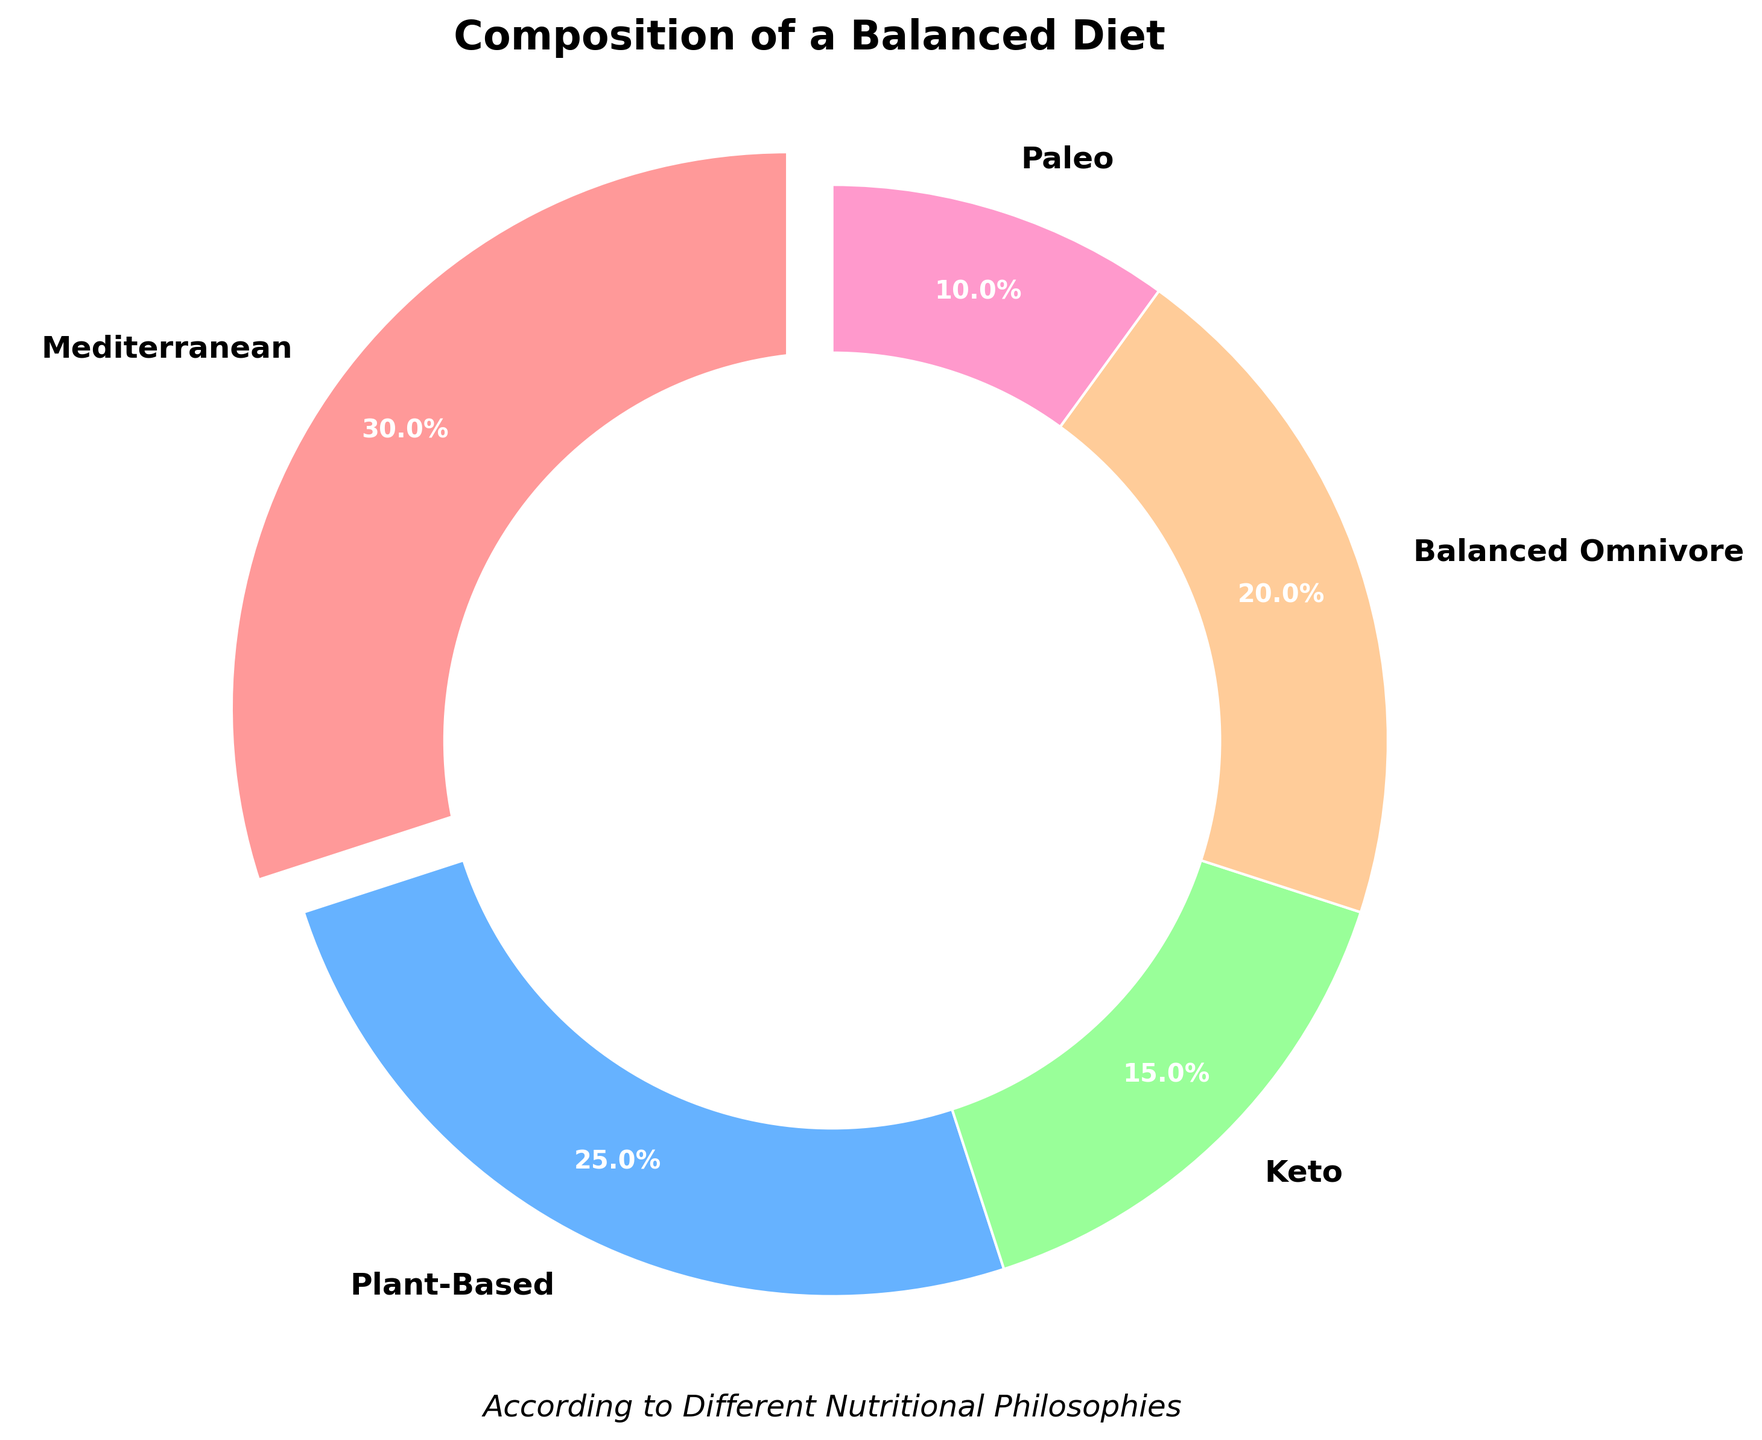What is the total percentage of the Mediterranean and Plant-Based diets? Add up the percentages of the Mediterranean (30%) and Plant-Based (25%) diets: 30 + 25 = 55
Answer: 55% Which diet type has the lowest representation in the pie chart? Compare the percentages of all diet types: Mediterranean (30%), Plant-Based (25%), Keto (15%), Balanced Omnivore (20%), and Paleo (10%). The Paleo diet has the lowest percentage.
Answer: Paleo Is the Keto diet represented more or less than 20% in the pie chart? The Keto diet has a percentage of 15%, which is less than 20%.
Answer: Less How much higher is the percentage of the Mediterranean diet compared to the Keto diet? Subtract the percentage of the Keto diet (15%) from the percentage of the Mediterranean diet (30%): 30 - 15 = 15
Answer: 15% How many diet types have a percentage greater than 15%? Identify the diet types with percentages greater than 15%: Mediterranean (30%), Plant-Based (25%), and Balanced Omnivore (20%). There are three such diet types.
Answer: 3 What is the percentage difference between the Balanced Omnivore and Paleo diets? Subtract the percentage of the Paleo diet (10%) from the Balanced Omnivore diet (20%): 20 - 10 = 10
Answer: 10% Which diet type has a pink-colored wedge in the pie chart? The Mediterranean diet's wedge is pink-colored as it is assigned the color code that corresponds to pink.
Answer: Mediterranean Is the percentage of the Paleo diet greater than or equal to the percentage of the Keto diet? The Paleo diet is 10% and the Keto diet is 15%. 10% is not greater than or equal to 15%.
Answer: No, it is less How do the combined percentages of the Mediterranean and Balanced Omnivore diets compare to the combined percentages of the Plant-Based and Keto diets? Combine the percentages of the Mediterranean (30%) and Balanced Omnivore (20%) diets: 30 + 20 = 50. Combine the percentages of the Plant-Based (25%) and Keto (15%) diets: 25 + 15 = 40. 50 is greater than 40.
Answer: Mediterranean and Balanced Omnivore are greater What color represents the Plant-Based diet wedge? Identify the color assigned to the Plant-Based diet wedge, which is light blue.
Answer: Light blue 